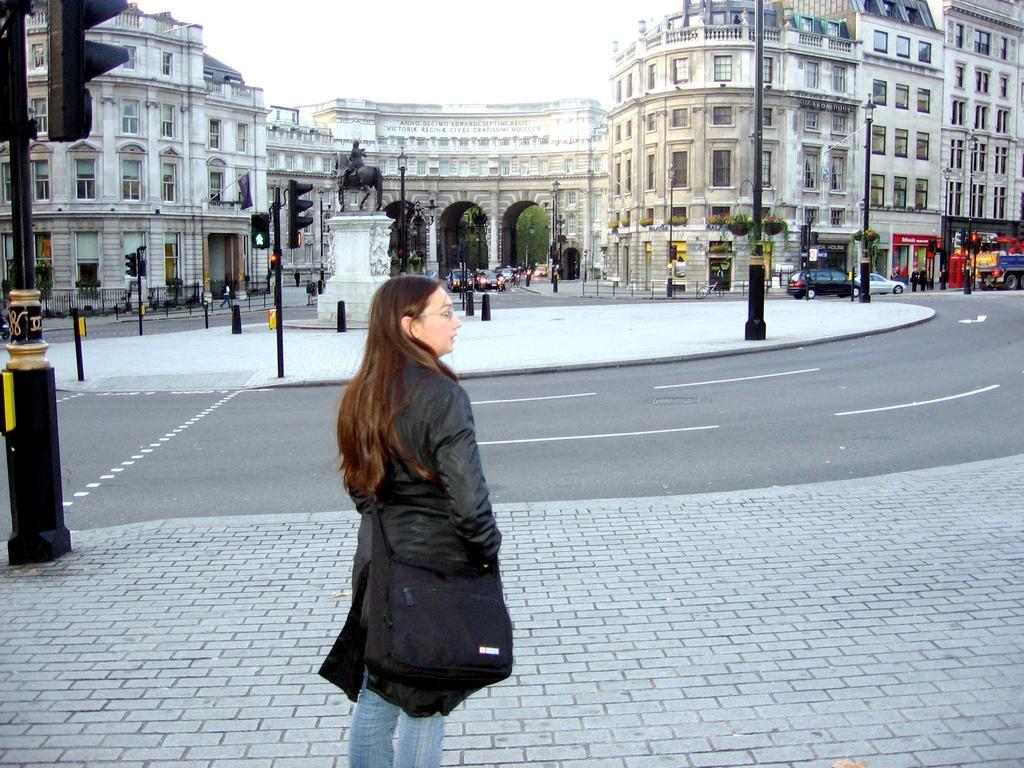Describe this image in one or two sentences. In this picture I can see the footpath in front, on which I can see a woman standing and she is wearing a bag. On the left side of this image I can see a traffic signal pole. In the middle of this picture I can see the roads, on which there are few cars and I can also see number of poles and another traffic signal pole. In the background I can see number of buildings, a statue, few people and few more poles. 